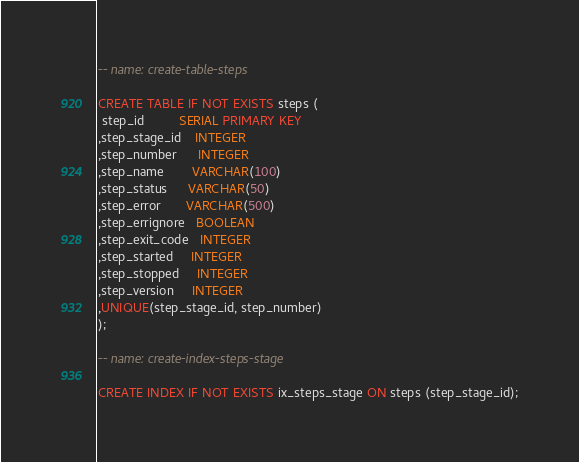<code> <loc_0><loc_0><loc_500><loc_500><_SQL_>-- name: create-table-steps

CREATE TABLE IF NOT EXISTS steps (
 step_id          SERIAL PRIMARY KEY
,step_stage_id    INTEGER
,step_number      INTEGER
,step_name        VARCHAR(100)
,step_status      VARCHAR(50)
,step_error       VARCHAR(500)
,step_errignore   BOOLEAN
,step_exit_code   INTEGER
,step_started     INTEGER
,step_stopped     INTEGER
,step_version     INTEGER
,UNIQUE(step_stage_id, step_number)
);

-- name: create-index-steps-stage

CREATE INDEX IF NOT EXISTS ix_steps_stage ON steps (step_stage_id);
</code> 